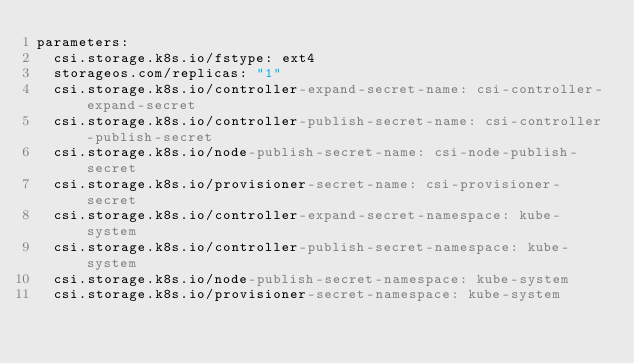Convert code to text. <code><loc_0><loc_0><loc_500><loc_500><_YAML_>parameters:
  csi.storage.k8s.io/fstype: ext4
  storageos.com/replicas: "1" 
  csi.storage.k8s.io/controller-expand-secret-name: csi-controller-expand-secret
  csi.storage.k8s.io/controller-publish-secret-name: csi-controller-publish-secret
  csi.storage.k8s.io/node-publish-secret-name: csi-node-publish-secret
  csi.storage.k8s.io/provisioner-secret-name: csi-provisioner-secret
  csi.storage.k8s.io/controller-expand-secret-namespace: kube-system  
  csi.storage.k8s.io/controller-publish-secret-namespace: kube-system  
  csi.storage.k8s.io/node-publish-secret-namespace: kube-system        
  csi.storage.k8s.io/provisioner-secret-namespace: kube-system  </code> 